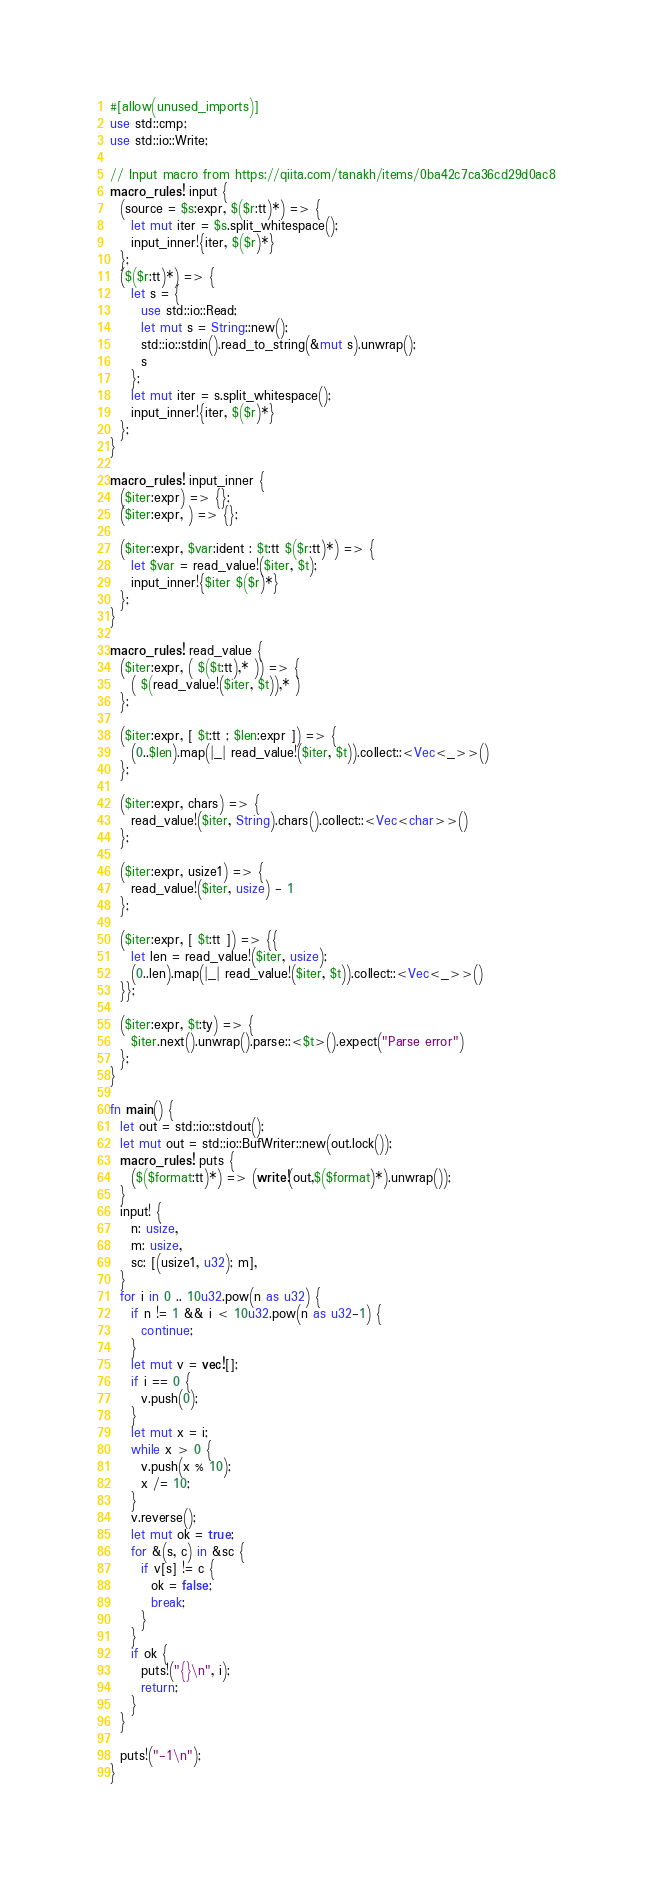<code> <loc_0><loc_0><loc_500><loc_500><_Rust_>#[allow(unused_imports)]
use std::cmp;
use std::io::Write;

// Input macro from https://qiita.com/tanakh/items/0ba42c7ca36cd29d0ac8
macro_rules! input {
  (source = $s:expr, $($r:tt)*) => {
    let mut iter = $s.split_whitespace();
    input_inner!{iter, $($r)*}
  };
  ($($r:tt)*) => {
    let s = {
      use std::io::Read;
      let mut s = String::new();
      std::io::stdin().read_to_string(&mut s).unwrap();
      s
    };
    let mut iter = s.split_whitespace();
    input_inner!{iter, $($r)*}
  };
}

macro_rules! input_inner {
  ($iter:expr) => {};
  ($iter:expr, ) => {};

  ($iter:expr, $var:ident : $t:tt $($r:tt)*) => {
    let $var = read_value!($iter, $t);
    input_inner!{$iter $($r)*}
  };
}

macro_rules! read_value {
  ($iter:expr, ( $($t:tt),* )) => {
    ( $(read_value!($iter, $t)),* )
  };

  ($iter:expr, [ $t:tt ; $len:expr ]) => {
    (0..$len).map(|_| read_value!($iter, $t)).collect::<Vec<_>>()
  };

  ($iter:expr, chars) => {
    read_value!($iter, String).chars().collect::<Vec<char>>()
  };

  ($iter:expr, usize1) => {
    read_value!($iter, usize) - 1
  };

  ($iter:expr, [ $t:tt ]) => {{
    let len = read_value!($iter, usize);
    (0..len).map(|_| read_value!($iter, $t)).collect::<Vec<_>>()
  }};

  ($iter:expr, $t:ty) => {
    $iter.next().unwrap().parse::<$t>().expect("Parse error")
  };
}

fn main() {
  let out = std::io::stdout();
  let mut out = std::io::BufWriter::new(out.lock());
  macro_rules! puts {
    ($($format:tt)*) => (write!(out,$($format)*).unwrap());
  }
  input! {
    n: usize,
    m: usize,
    sc: [(usize1, u32); m],
  }
  for i in 0 .. 10u32.pow(n as u32) {
    if n != 1 && i < 10u32.pow(n as u32-1) {
      continue;
    }
    let mut v = vec![];
    if i == 0 {
      v.push(0);
    }
    let mut x = i;
    while x > 0 {
      v.push(x % 10);
      x /= 10;
    }
    v.reverse();
    let mut ok = true;
    for &(s, c) in &sc {
      if v[s] != c {
        ok = false;
        break;
      }
    }
    if ok {
      puts!("{}\n", i);
      return;
    }
  }

  puts!("-1\n");
}
</code> 